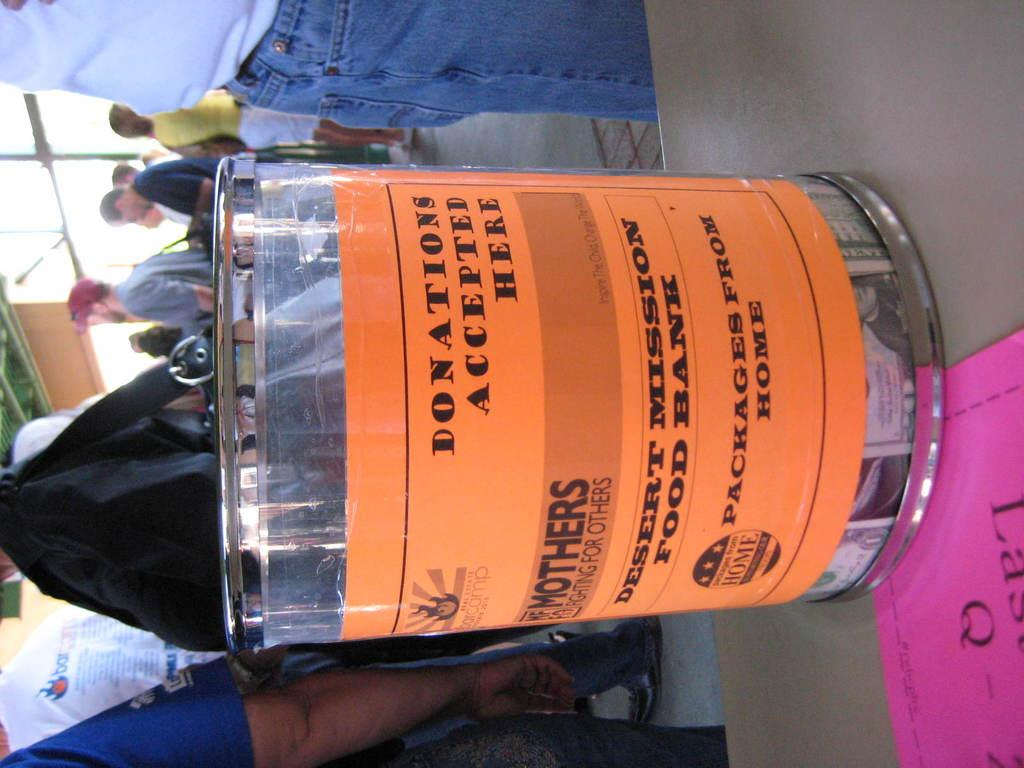What is the main object on the table in the image? There is an object on a table in the image, but the specific object is not mentioned in the facts. What is placed on the table alongside the main object? There is a paper on the table in the image. What can be seen in the background of the image? In the background, there is a group of people standing on the floor and rods visible. What type of berry is being used as a care product for the planes in the image? There is no mention of berries, care products, or planes in the image. 